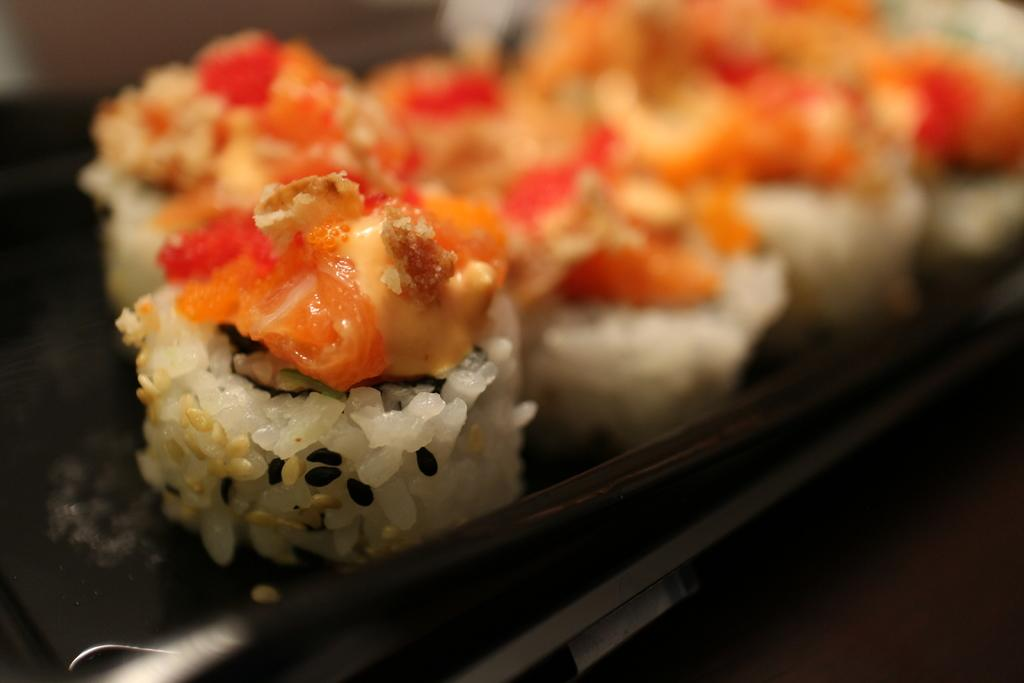What object is present in the image that is used to hold items? There is a black tray in the image that is used to hold items. What type of food can be seen on the tray? The food on the tray is made up of rice. What angle does the roll take when placed on the tray? There is no roll present in the image, so it is not possible to determine the angle at which it would be placed on the tray. 